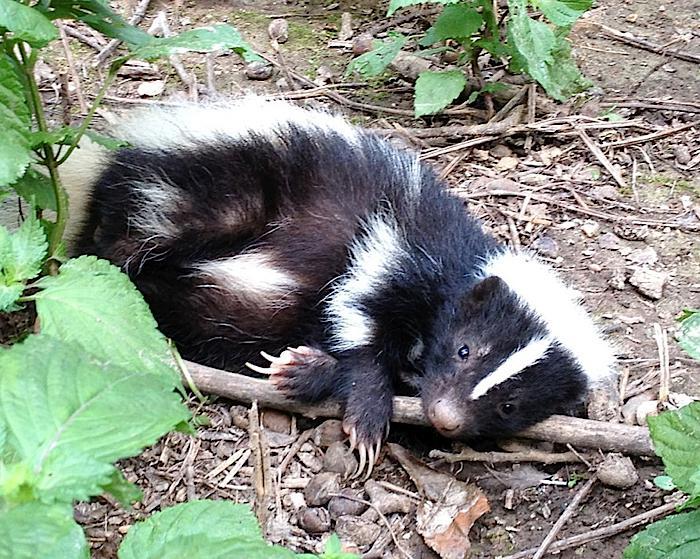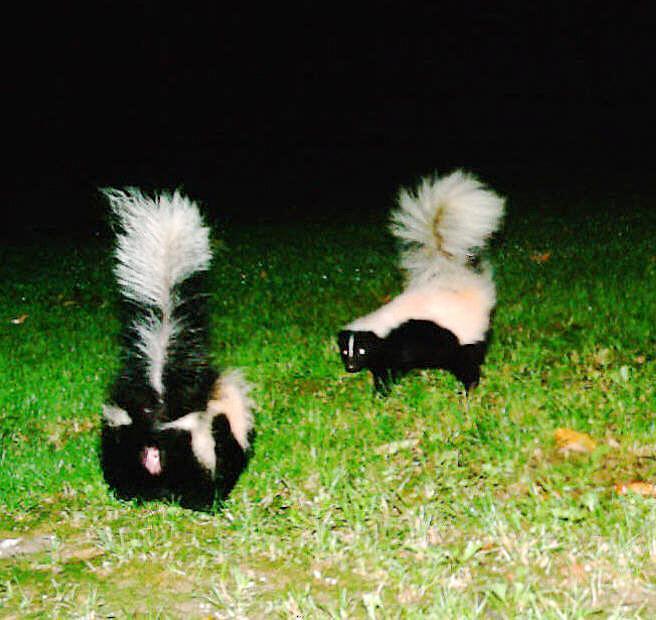The first image is the image on the left, the second image is the image on the right. Examine the images to the left and right. Is the description "The combined images contain at least four skunks, including two side-by side with their faces pointing toward each other." accurate? Answer yes or no. No. The first image is the image on the left, the second image is the image on the right. For the images displayed, is the sentence "Three or fewer mammals are visible." factually correct? Answer yes or no. Yes. 